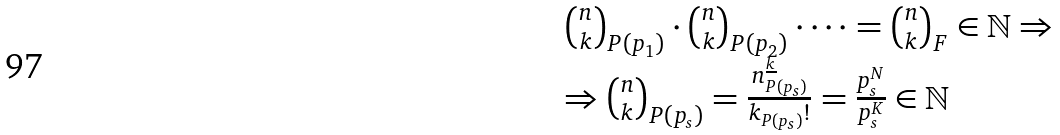Convert formula to latex. <formula><loc_0><loc_0><loc_500><loc_500>\begin{array} { l } { n \choose k } _ { P ( p _ { 1 } ) } \cdot { n \choose k } _ { P ( p _ { 2 } ) } \cdot \dots = { n \choose k } _ { F } \in \mathbb { N } \Rightarrow \\ \Rightarrow { n \choose k } _ { P ( p _ { s } ) } = \frac { n _ { P ( p _ { s } ) } ^ { \underline { k } } } { k _ { P ( p _ { s } ) } ! } = \frac { p _ { s } ^ { N } } { p _ { s } ^ { K } } \in \mathbb { N } \end{array}</formula> 